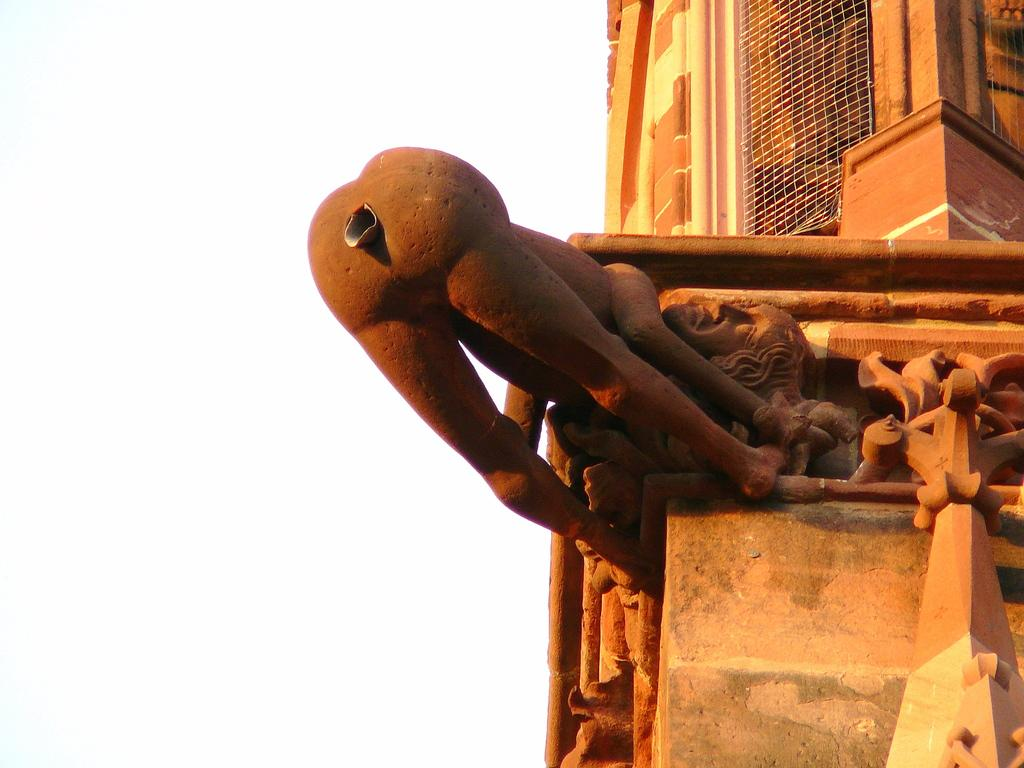What is the main subject of the image? There is a statue of a human in the image. What can be seen on the right side of the image? There is a building on the right side of the image. What is unique about the building? The building has an iron net. What is visible on the left side of the image? The sky is visible on the left side of the image. What type of shoe is the statue wearing in the image? The statue does not have a shoe, as it is a sculpture and not a real person. 